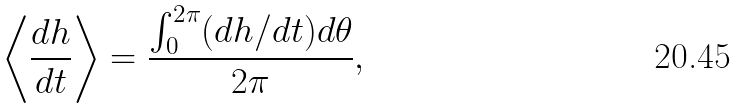<formula> <loc_0><loc_0><loc_500><loc_500>\left < \frac { d h } { d t } \right > = \frac { \int ^ { 2 \pi } _ { 0 } ( d h / d t ) d \theta } { 2 \pi } ,</formula> 